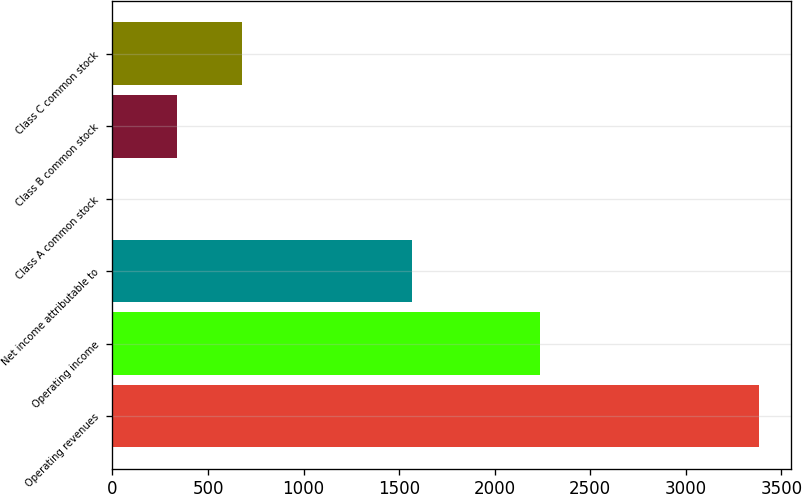Convert chart. <chart><loc_0><loc_0><loc_500><loc_500><bar_chart><fcel>Operating revenues<fcel>Operating income<fcel>Net income attributable to<fcel>Class A common stock<fcel>Class B common stock<fcel>Class C common stock<nl><fcel>3382<fcel>2238<fcel>1569<fcel>0.63<fcel>338.77<fcel>676.91<nl></chart> 